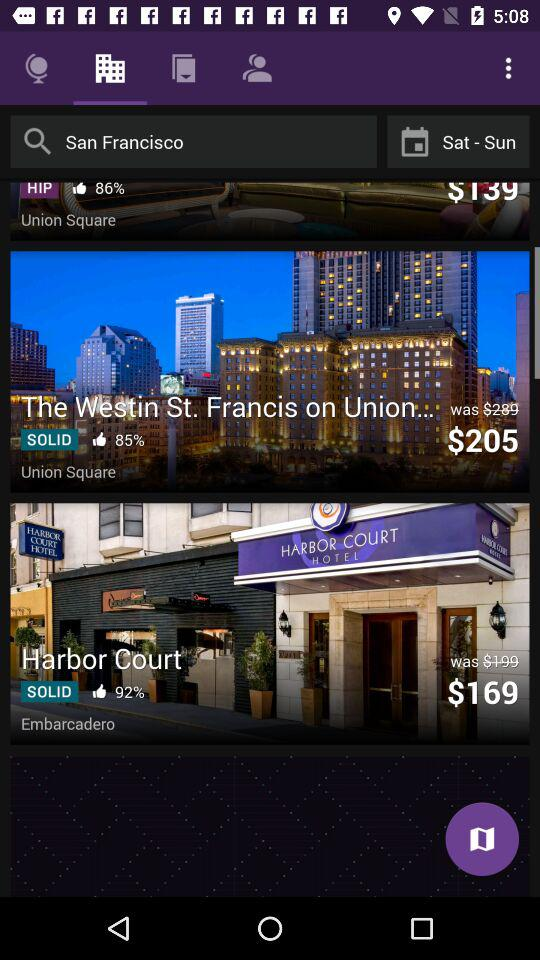What is the cost of a booking at "The Westin St. Francis on Union..."? The cost of a booking at "The Westin St. Francis on Union..." is $205. 